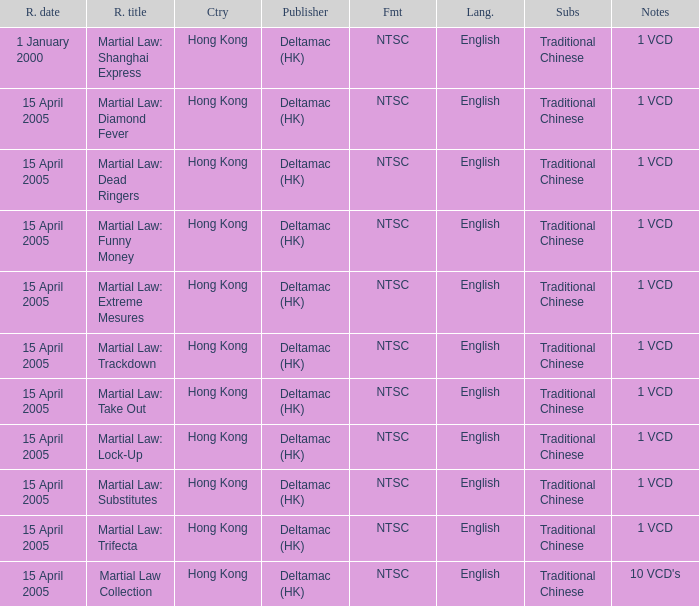Who was the publisher of Martial Law: Dead Ringers? Deltamac (HK). 